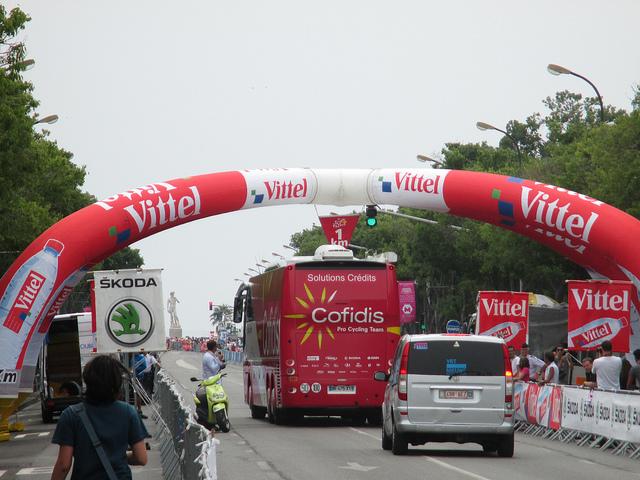What does the white sign say on the left?
Answer briefly. Skoda. How many cars are behind the bus?
Concise answer only. 1. Is it sunny outside?
Short answer required. No. 